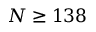Convert formula to latex. <formula><loc_0><loc_0><loc_500><loc_500>N \geq 1 3 8</formula> 